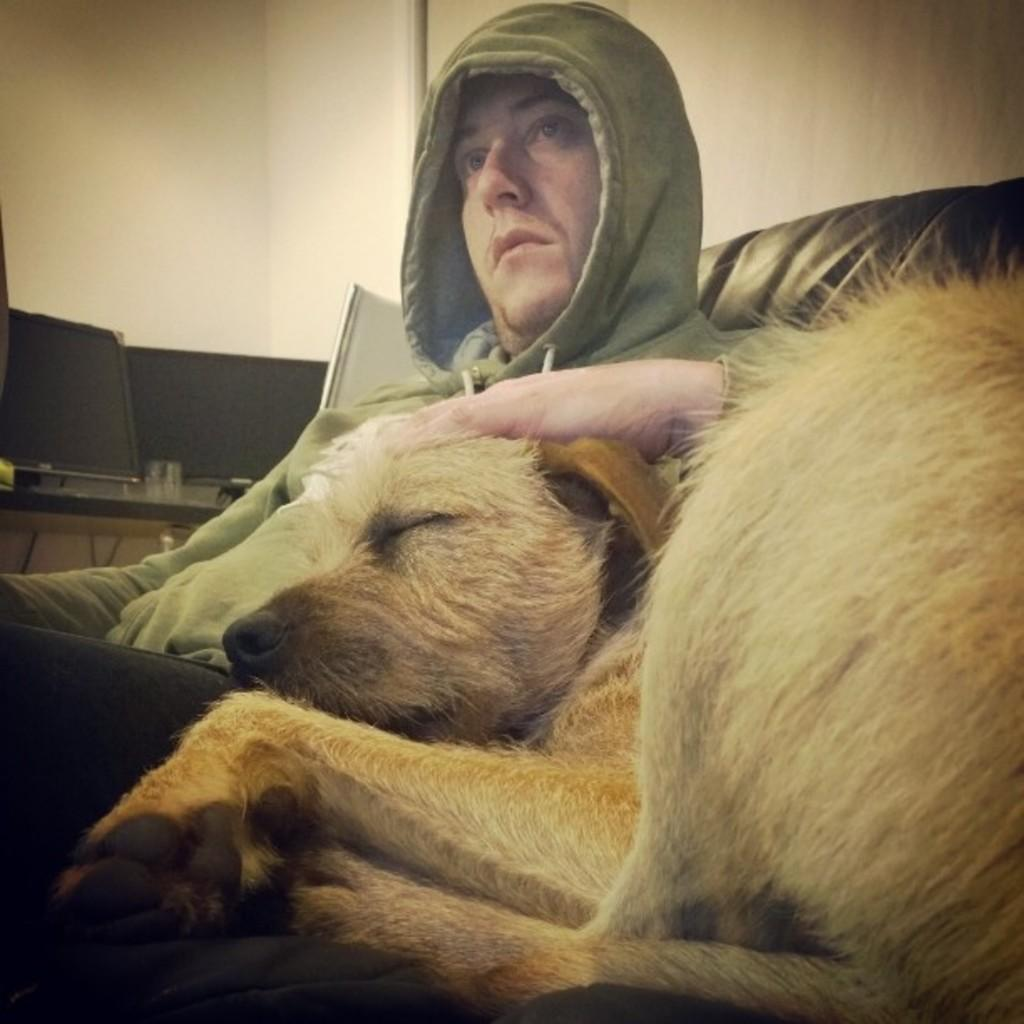What is the man in the image doing? The man is sitting on a chair in the image. What can be seen behind the man? There is a dog behind the man. What is present in the background of the image? There is a monitor and a wall in the background of the image. What type of trousers is the snake wearing in the image? There is no snake or trousers present in the image. Is the man playing a game of chess with the dog in the image? There is no chess game or interaction between the man and the dog in the image. 